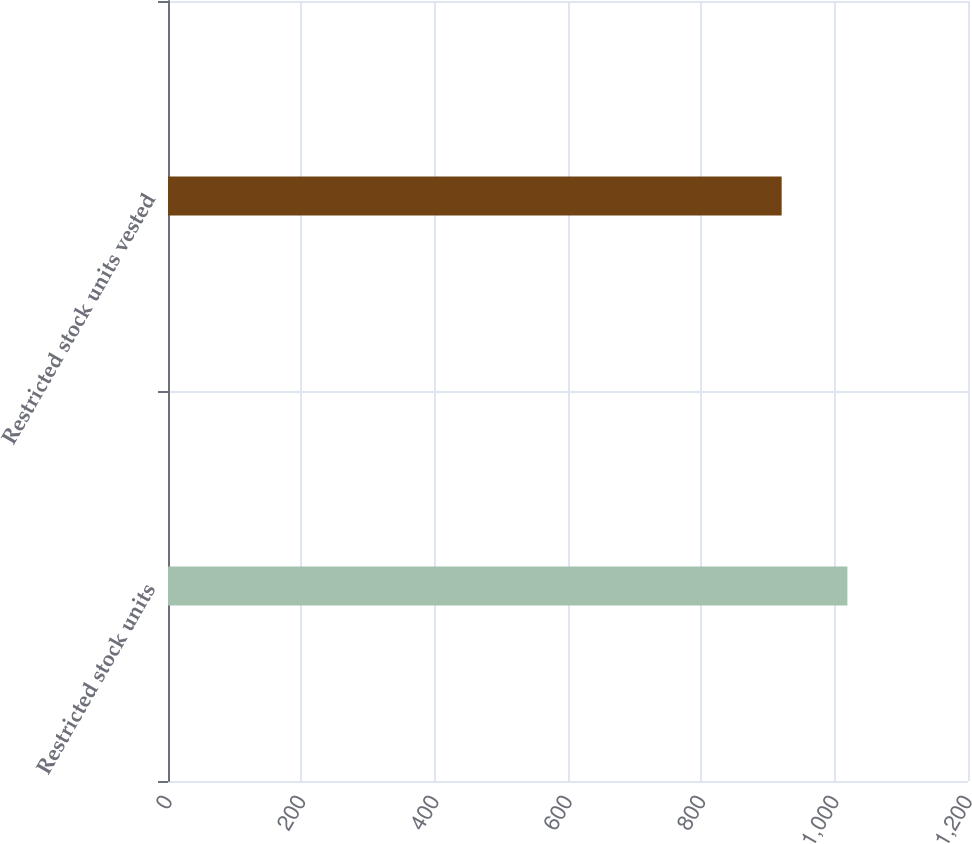<chart> <loc_0><loc_0><loc_500><loc_500><bar_chart><fcel>Restricted stock units<fcel>Restricted stock units vested<nl><fcel>1019.1<fcel>920.5<nl></chart> 